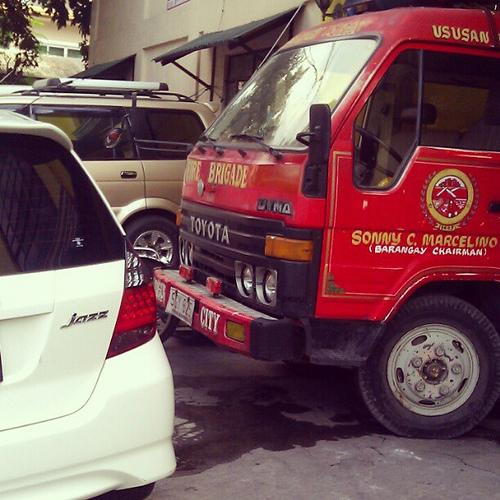What unique feature is found on the back of one of the vehicles? The word "Jazz" is written in silver letters on the back of the white van. List three elements that are present in the image, mentioning their position relative to the main object. A white car is located near the red truck, a gold-colored SUV is close, and a building with an open awning is behind them. Mention the color and location of an awning in the image. A green awning is present on a building above the gold vehicle in the frame. Describe the notable attribute of a tire in the image. A tire on the truck has a silver wheel with black tires, and there are 5 lug nuts visible. List two different types of vehicles parked in the lot. A red Toyota truck and a gold-colored SUV are parked in the lot. Describe one of the lighting elements found in the image. An orange light is present on the front of the red truck. Comment on a particular detail found on one of the vehicles. A red tail light is visible on the back of the white van, providing additional detail. Mention the type of environment the image is in and an action that took place. The image shows vehicles in a parking lot, and there is a spill of water on the ground indicating wetness. Describe the dominant object in the image along with its color. A red Toyota truck is the main object in the image, occupying a large part of the frame. Name a specific company logo present on one of the vehicles and its location. A silver Toyota logo is prominently displayed on the front of the red truck. Point out the blue Toyota logo on the front of the truck. There is no blue Toyota logo on the truck's front, only silver letters that say Toyota. Can you locate a purple awning on the building behind the parked vehicles? There is no purple awning on the building; it has a green awning. Can you see a gold emblem with the word "Rock" written on the back of a car? There is no gold emblem with "Rock" written on the back of a car, only a silver word "Jazz" on the back of a van. Please find a large green car in the image with a roof rack on it. There is no large green car with a roof rack in the image, only a gold colored SUV with a roof rack. There is an icy patch on the ground near the vehicles, could you please locate it? There is no icy patch on the ground in the image, only a spill of water. Can you find a black steering wheel with gold writing in the red truck? The red truck has a black steering wheel, but it doesn't have gold writing on it. Locate the orange license plate on the front of the truck. There is no orange license plate on the front of the truck, only a white license plate. Is there a blue truck in the image with a white front bumper? There is no blue truck in the image; the truck is red and has a red front bumper, not white. Identify the yellow tail light on the back of the white van. There is no yellow tail light on the back of the white van, only a red tail light. Is there a black tire with a yellow rim on the red truck? There is no black tire with a yellow rim on the red truck, only a black tire with a white rim. 